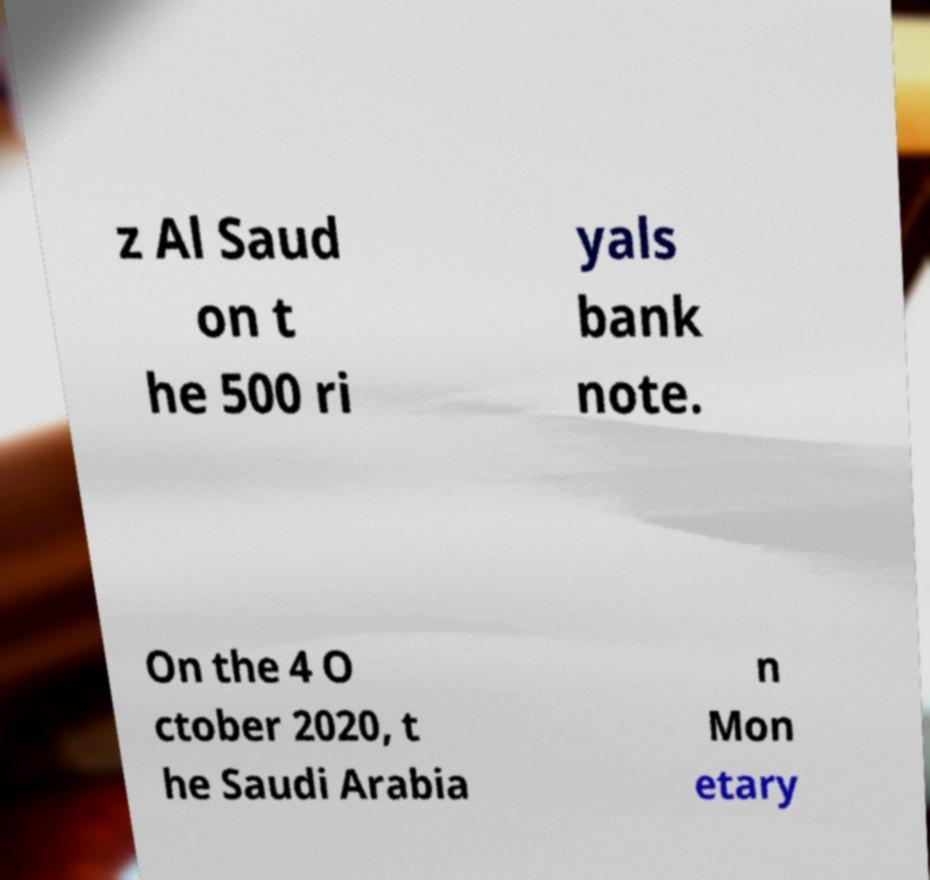For documentation purposes, I need the text within this image transcribed. Could you provide that? z Al Saud on t he 500 ri yals bank note. On the 4 O ctober 2020, t he Saudi Arabia n Mon etary 